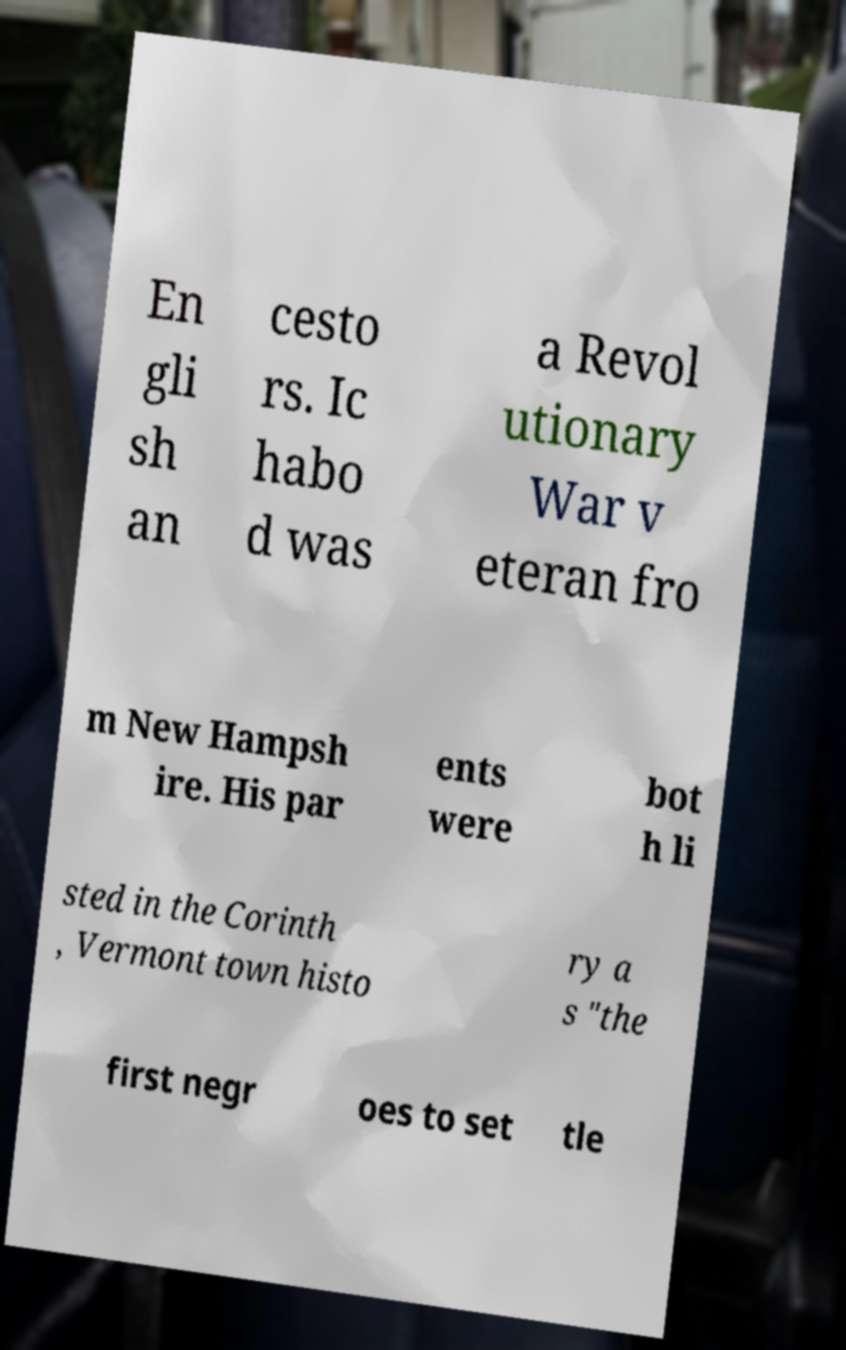Can you accurately transcribe the text from the provided image for me? En gli sh an cesto rs. Ic habo d was a Revol utionary War v eteran fro m New Hampsh ire. His par ents were bot h li sted in the Corinth , Vermont town histo ry a s "the first negr oes to set tle 